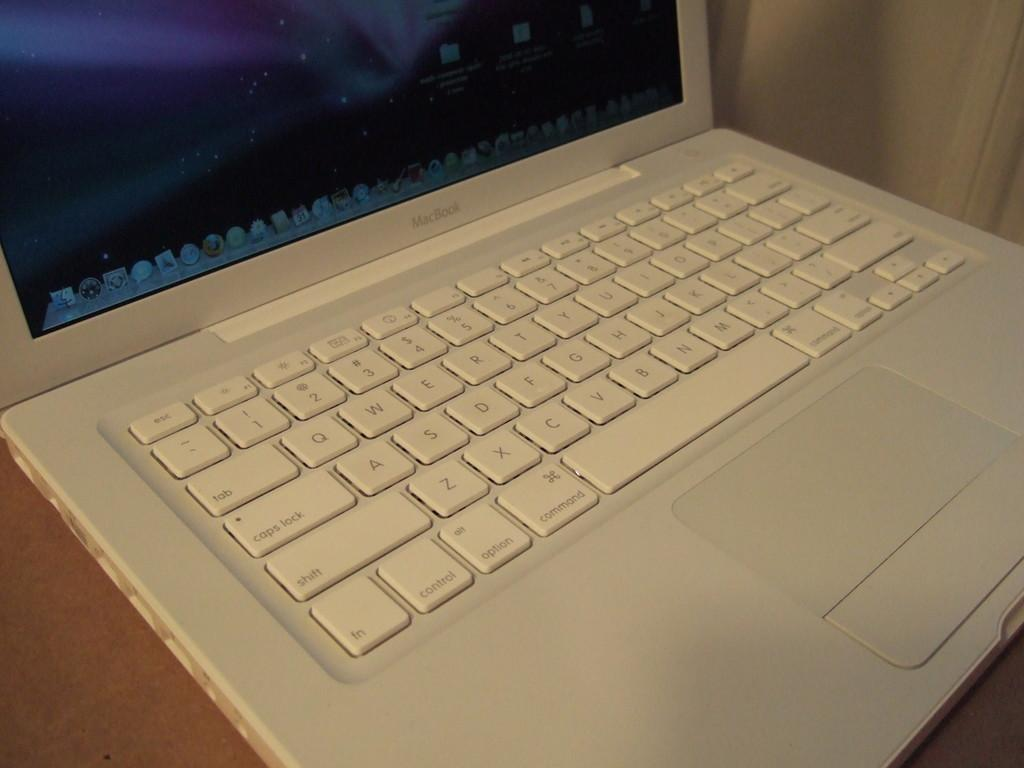Provide a one-sentence caption for the provided image. white macbook computer which is placed on the counter. 